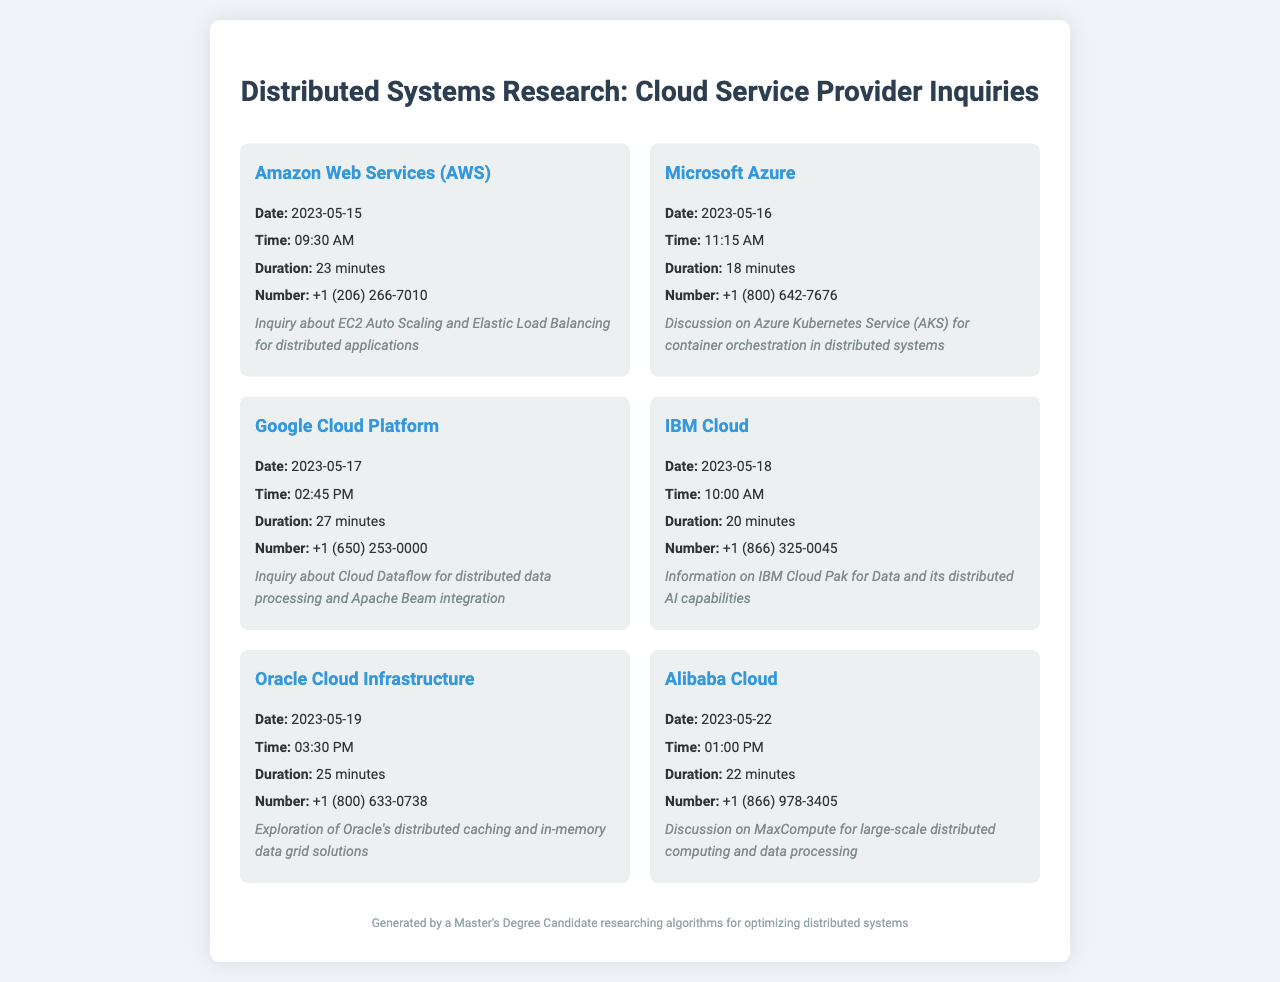what is the date of the call to Amazon Web Services? The date listed in the document for the AWS call is specifically mentioned.
Answer: 2023-05-15 how long was the call with Microsoft Azure? The duration of the call is explicitly stated in the details for Microsoft Azure.
Answer: 18 minutes what was the main topic of discussion for the Google Cloud Platform call? The purpose of the call is provided in the document, summarizing the focus of the inquiry for Google Cloud Platform.
Answer: Cloud Dataflow for distributed data processing which cloud provider was contacted on May 22, 2023? The specific date allows us to find the associated cloud provider in the records.
Answer: Alibaba Cloud how many minutes was the call with IBM Cloud? The duration of the IBM Cloud call is provided, allowing for a straightforward retrieval of this information.
Answer: 20 minutes what was the inquiry related to in the call with Oracle Cloud Infrastructure? The purpose statement summarizes the inquiry topic for Oracle Cloud.
Answer: distributed caching and in-memory data grid solutions which company’s inquiry lasted the longest? A comparison of the durations listed allows for identifying the longest call easily.
Answer: Google Cloud Platform how many calls were made to cloud service providers in total? The total number of records listed indicates how many calls were made.
Answer: 6 